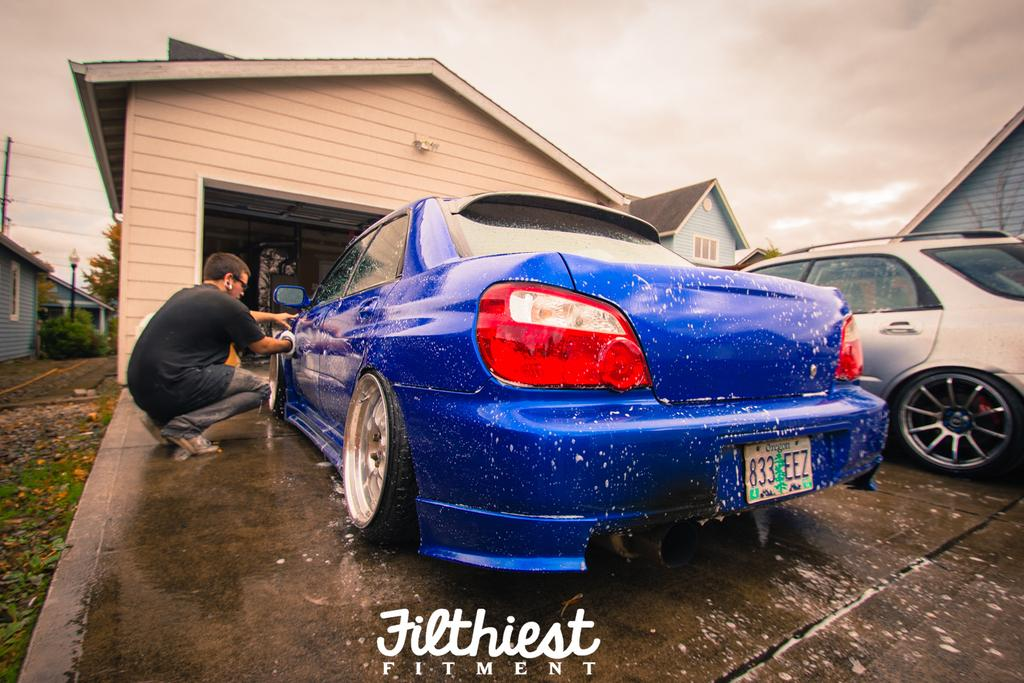What is the person in the image doing? There is a person washing a car in the image. What can be seen in the background of the image? There are houses and a car visible in the background of the image. What type of sweater is the person wearing while washing the car? There is no information about the person's clothing in the image, so we cannot determine if they are wearing a sweater or any other type of clothing. 